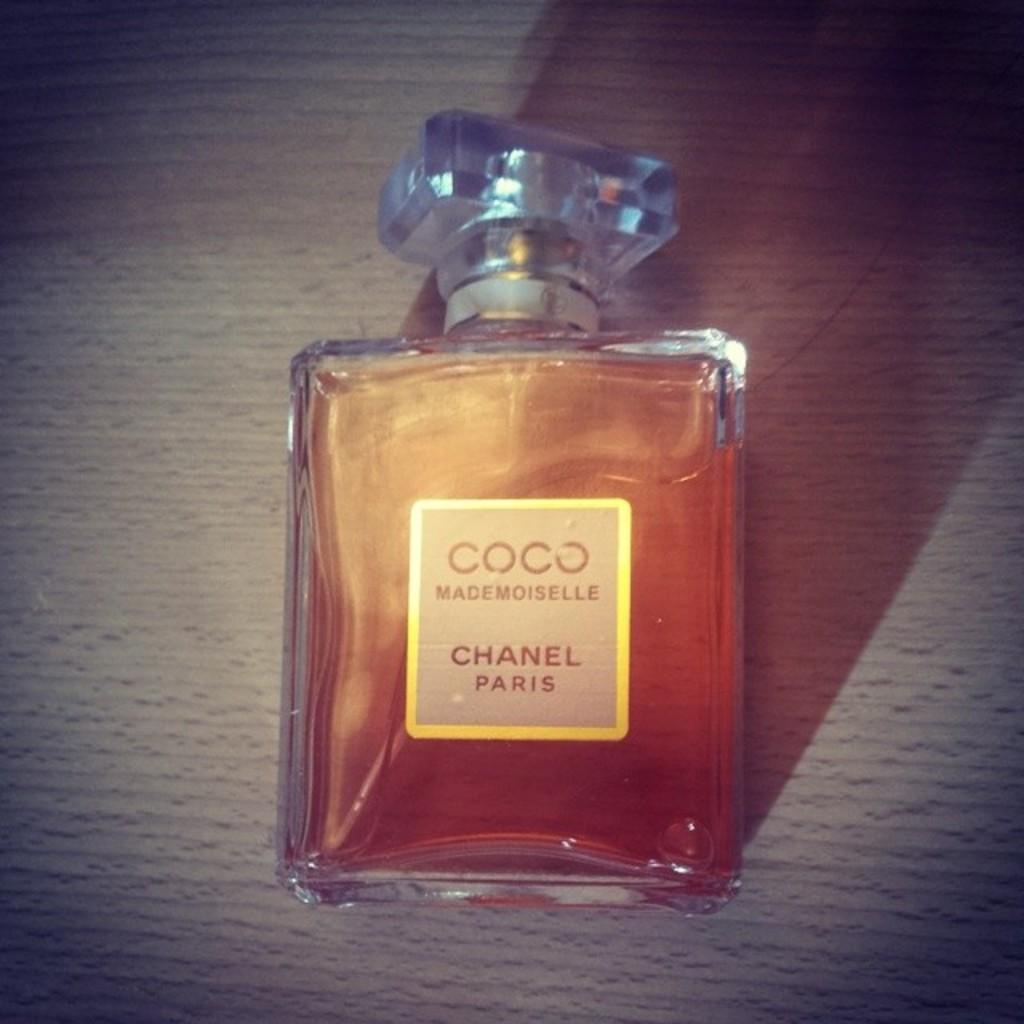<image>
Give a short and clear explanation of the subsequent image. A bottle of Coco Chanel rests on a wooden surface. 